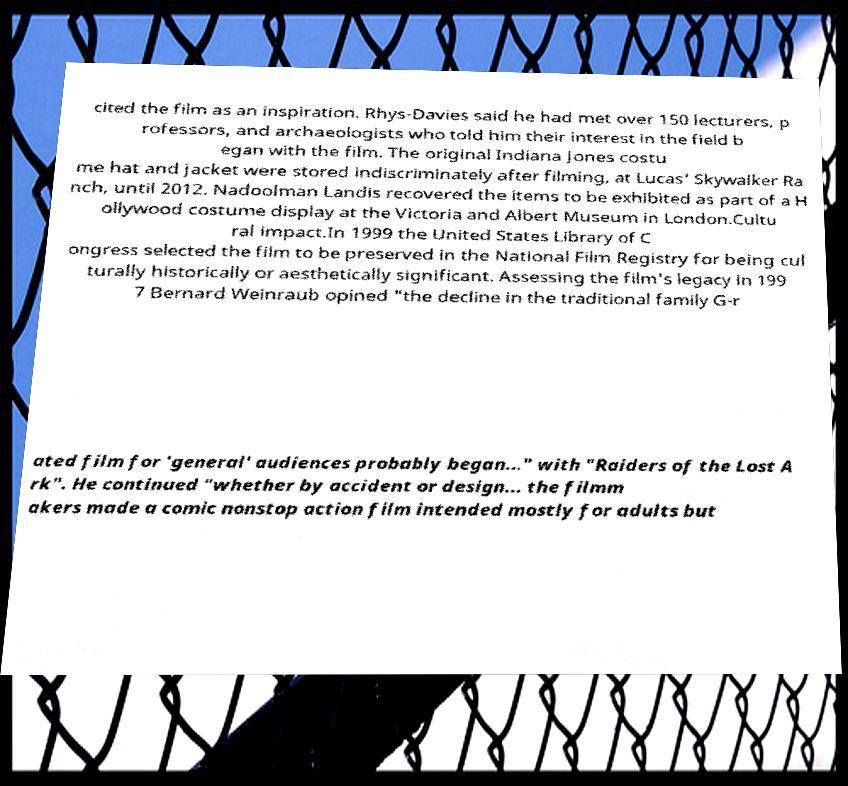Could you assist in decoding the text presented in this image and type it out clearly? cited the film as an inspiration. Rhys-Davies said he had met over 150 lecturers, p rofessors, and archaeologists who told him their interest in the field b egan with the film. The original Indiana Jones costu me hat and jacket were stored indiscriminately after filming, at Lucas' Skywalker Ra nch, until 2012. Nadoolman Landis recovered the items to be exhibited as part of a H ollywood costume display at the Victoria and Albert Museum in London.Cultu ral impact.In 1999 the United States Library of C ongress selected the film to be preserved in the National Film Registry for being cul turally historically or aesthetically significant. Assessing the film's legacy in 199 7 Bernard Weinraub opined "the decline in the traditional family G-r ated film for 'general' audiences probably began..." with "Raiders of the Lost A rk". He continued "whether by accident or design... the filmm akers made a comic nonstop action film intended mostly for adults but 